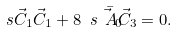<formula> <loc_0><loc_0><loc_500><loc_500>\ s { \vec { C } _ { 1 } } { \vec { C } _ { 1 } } + 8 \ s { \bar { \vec { A } _ { 0 } } } { \vec { C } _ { 3 } } = 0 .</formula> 